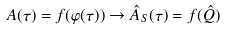Convert formula to latex. <formula><loc_0><loc_0><loc_500><loc_500>A ( \tau ) = f ( \varphi ( \tau ) ) \to \hat { A } _ { S } ( \tau ) = f ( \hat { Q } )</formula> 